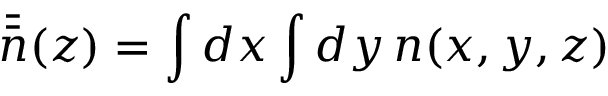<formula> <loc_0><loc_0><loc_500><loc_500>\bar { \bar { n } } ( z ) = \int d x \int d y \, n ( x , y , z )</formula> 